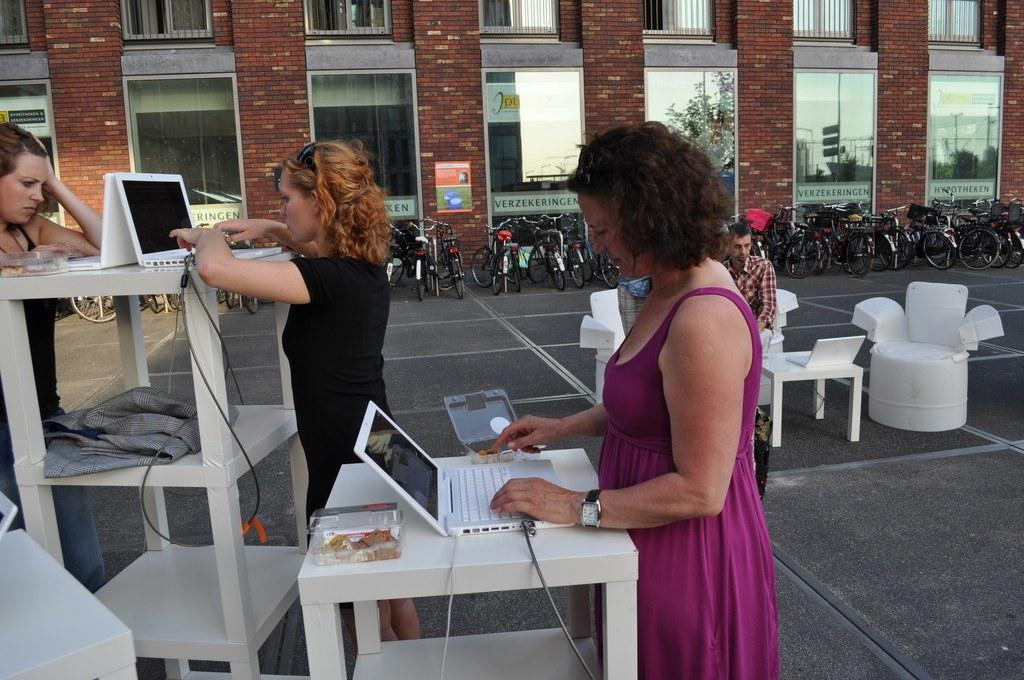How many people are in the image? There is a group of persons in the image, but the exact number is not specified. What are the persons in the image doing? The persons are doing their work. What can be seen in the background of the image? There are cycles and a building in the background of the image. What type of kettle is being used by the persons in the image? There is no kettle present in the image. How does the stomach of the persons in the image feel while they are working? The image does not provide information about the stomach feelings of the persons in the image. 